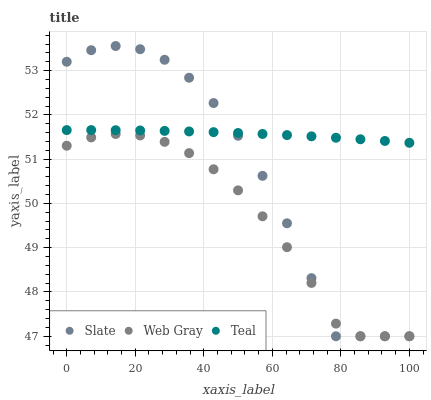Does Web Gray have the minimum area under the curve?
Answer yes or no. Yes. Does Teal have the maximum area under the curve?
Answer yes or no. Yes. Does Teal have the minimum area under the curve?
Answer yes or no. No. Does Web Gray have the maximum area under the curve?
Answer yes or no. No. Is Teal the smoothest?
Answer yes or no. Yes. Is Slate the roughest?
Answer yes or no. Yes. Is Web Gray the smoothest?
Answer yes or no. No. Is Web Gray the roughest?
Answer yes or no. No. Does Slate have the lowest value?
Answer yes or no. Yes. Does Teal have the lowest value?
Answer yes or no. No. Does Slate have the highest value?
Answer yes or no. Yes. Does Teal have the highest value?
Answer yes or no. No. Is Web Gray less than Teal?
Answer yes or no. Yes. Is Teal greater than Web Gray?
Answer yes or no. Yes. Does Web Gray intersect Slate?
Answer yes or no. Yes. Is Web Gray less than Slate?
Answer yes or no. No. Is Web Gray greater than Slate?
Answer yes or no. No. Does Web Gray intersect Teal?
Answer yes or no. No. 